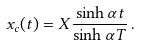Convert formula to latex. <formula><loc_0><loc_0><loc_500><loc_500>x _ { c } ( t ) = X \frac { \sinh \alpha t } { \sinh \alpha T } \, .</formula> 